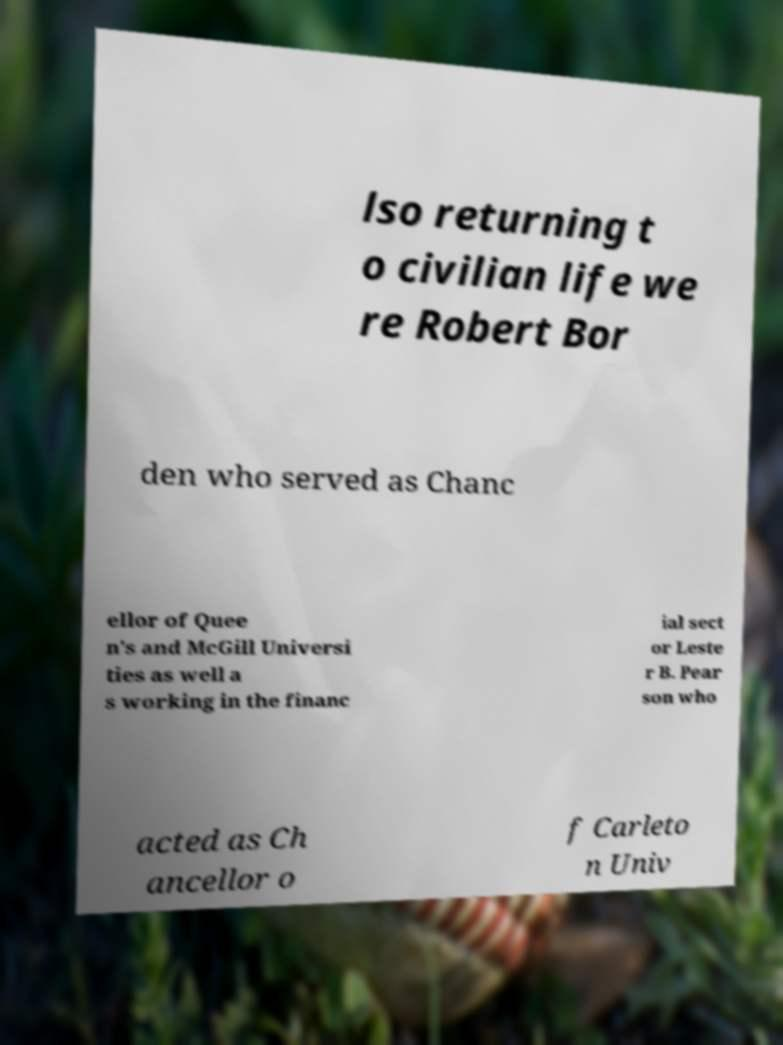What messages or text are displayed in this image? I need them in a readable, typed format. lso returning t o civilian life we re Robert Bor den who served as Chanc ellor of Quee n's and McGill Universi ties as well a s working in the financ ial sect or Leste r B. Pear son who acted as Ch ancellor o f Carleto n Univ 